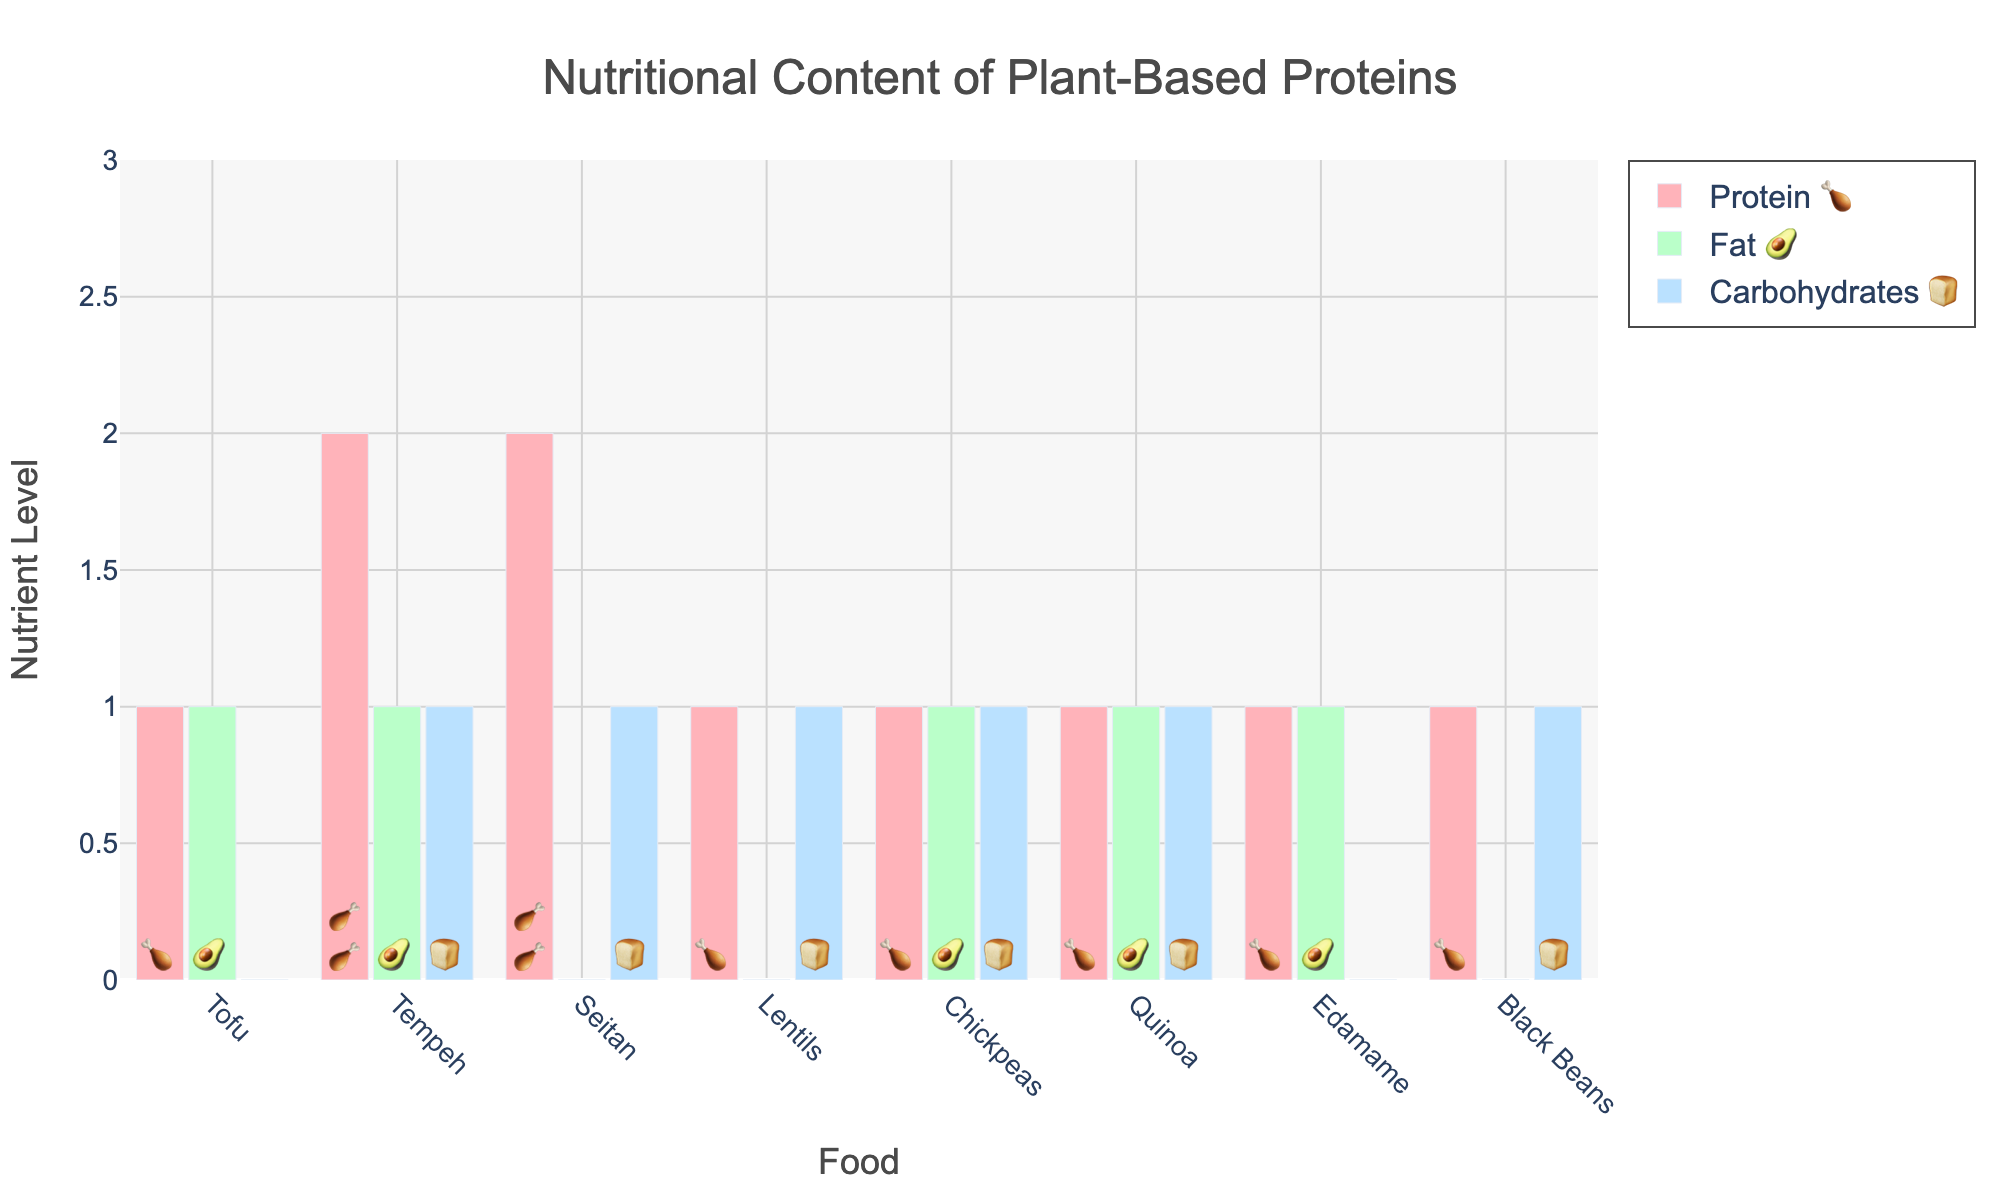What's the food with the highest protein content? To determine the food with the highest protein content, look for the food item with the most protein emojis (🍗). Seitan has 5 protein emojis, which is the highest.
Answer: Seitan Which food has the most balanced macronutrient distribution? The balance can be seen by choosing the food with similar numbers of protein, fat, and carbohydrate emojis. Tofu, Tempeh, and Edamame have very similar amounts of each nutrient emoji. Tofu has 3 proteins, 2 fats, and 1 carbohydrate, while Tempeh has 4 proteins, 2 fats, 2 carbohydrates, and Edamame has 3 proteins, 2 fats, and 1 carbohydrate.
Answer: Tofu, Tempeh, Edamame How does the fat content of Tempeh compare with that of Quinoa? Compare the number of fat emojis (🥑) for Tempeh and Quinoa. Both have 2 fat emojis.
Answer: Equal Which food has the highest carbohydrate content? To find the food with the highest carbohydrate content, look for the one with the most carbohydrate emojis (🍞). Lentils, Chickpeas, Quinoa, and Black Beans each have 3 carbohydrate emojis, which is the highest in the dataset.
Answer: Lentils, Chickpeas, Quinoa, Black Beans What’s the ratio of protein to fat in Seitan? Count the number of protein emojis (🍗) and the number of fat emojis (🥑) in Seitan. Seitan has 5 protein emojis and 1 fat emoji, giving a ratio of 5:1.
Answer: 5:1 Which food has double the amount of protein compared to Carbohydrates? Look for a food item where the number of protein emojis (🍗) is twice the number of carbohydrate emojis (🍞). Seitan has 5 proteins and 2 carbohydrates, and Tempeh has 4 proteins and 2 carbohydrates, both satisfy this condition.
Answer: Seitan, Tempeh Which food has the least amount of fat? Identify the food with the fewest fat emojis (🥑). Seitan, Lentils, and Black Beans each have 1 fat emoji.
Answer: Seitan, Lentils, Black Beans 